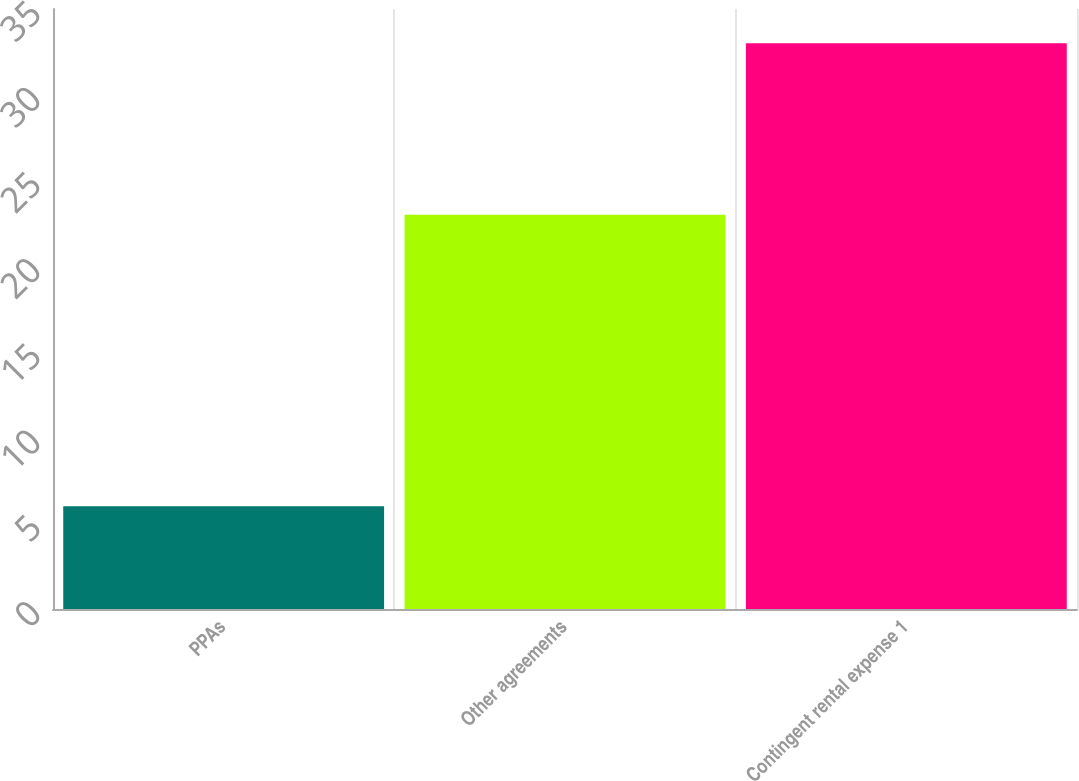Convert chart to OTSL. <chart><loc_0><loc_0><loc_500><loc_500><bar_chart><fcel>PPAs<fcel>Other agreements<fcel>Contingent rental expense 1<nl><fcel>6<fcel>23<fcel>33<nl></chart> 